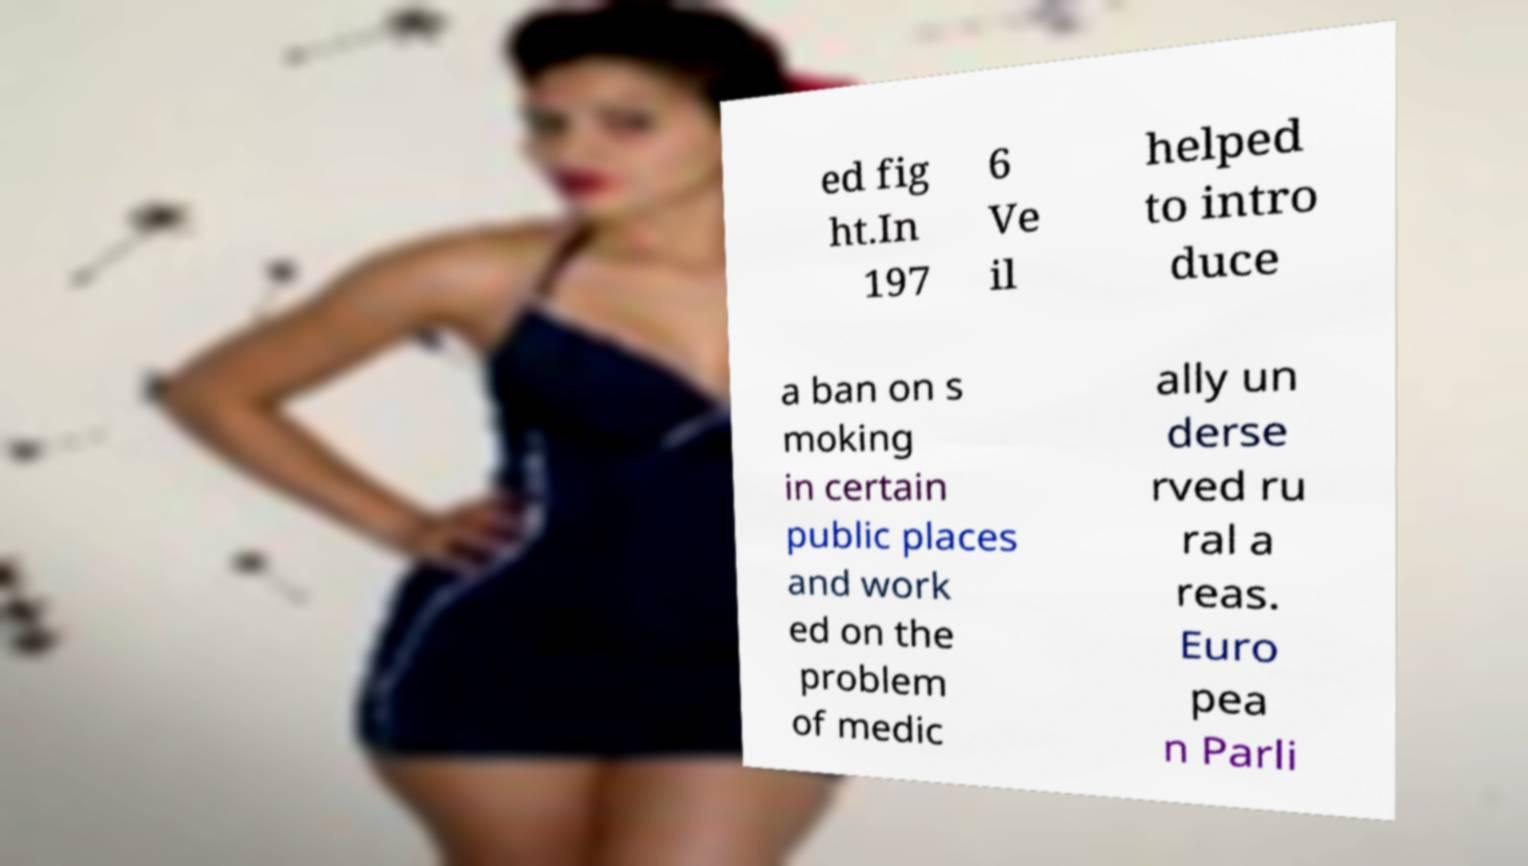I need the written content from this picture converted into text. Can you do that? ed fig ht.In 197 6 Ve il helped to intro duce a ban on s moking in certain public places and work ed on the problem of medic ally un derse rved ru ral a reas. Euro pea n Parli 